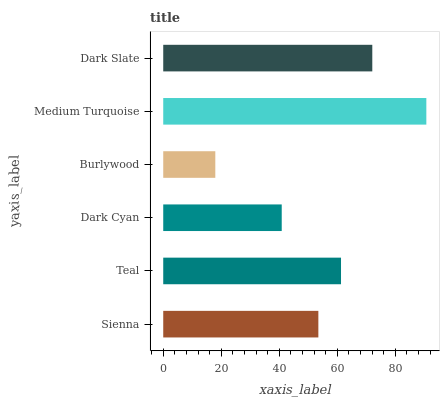Is Burlywood the minimum?
Answer yes or no. Yes. Is Medium Turquoise the maximum?
Answer yes or no. Yes. Is Teal the minimum?
Answer yes or no. No. Is Teal the maximum?
Answer yes or no. No. Is Teal greater than Sienna?
Answer yes or no. Yes. Is Sienna less than Teal?
Answer yes or no. Yes. Is Sienna greater than Teal?
Answer yes or no. No. Is Teal less than Sienna?
Answer yes or no. No. Is Teal the high median?
Answer yes or no. Yes. Is Sienna the low median?
Answer yes or no. Yes. Is Sienna the high median?
Answer yes or no. No. Is Burlywood the low median?
Answer yes or no. No. 